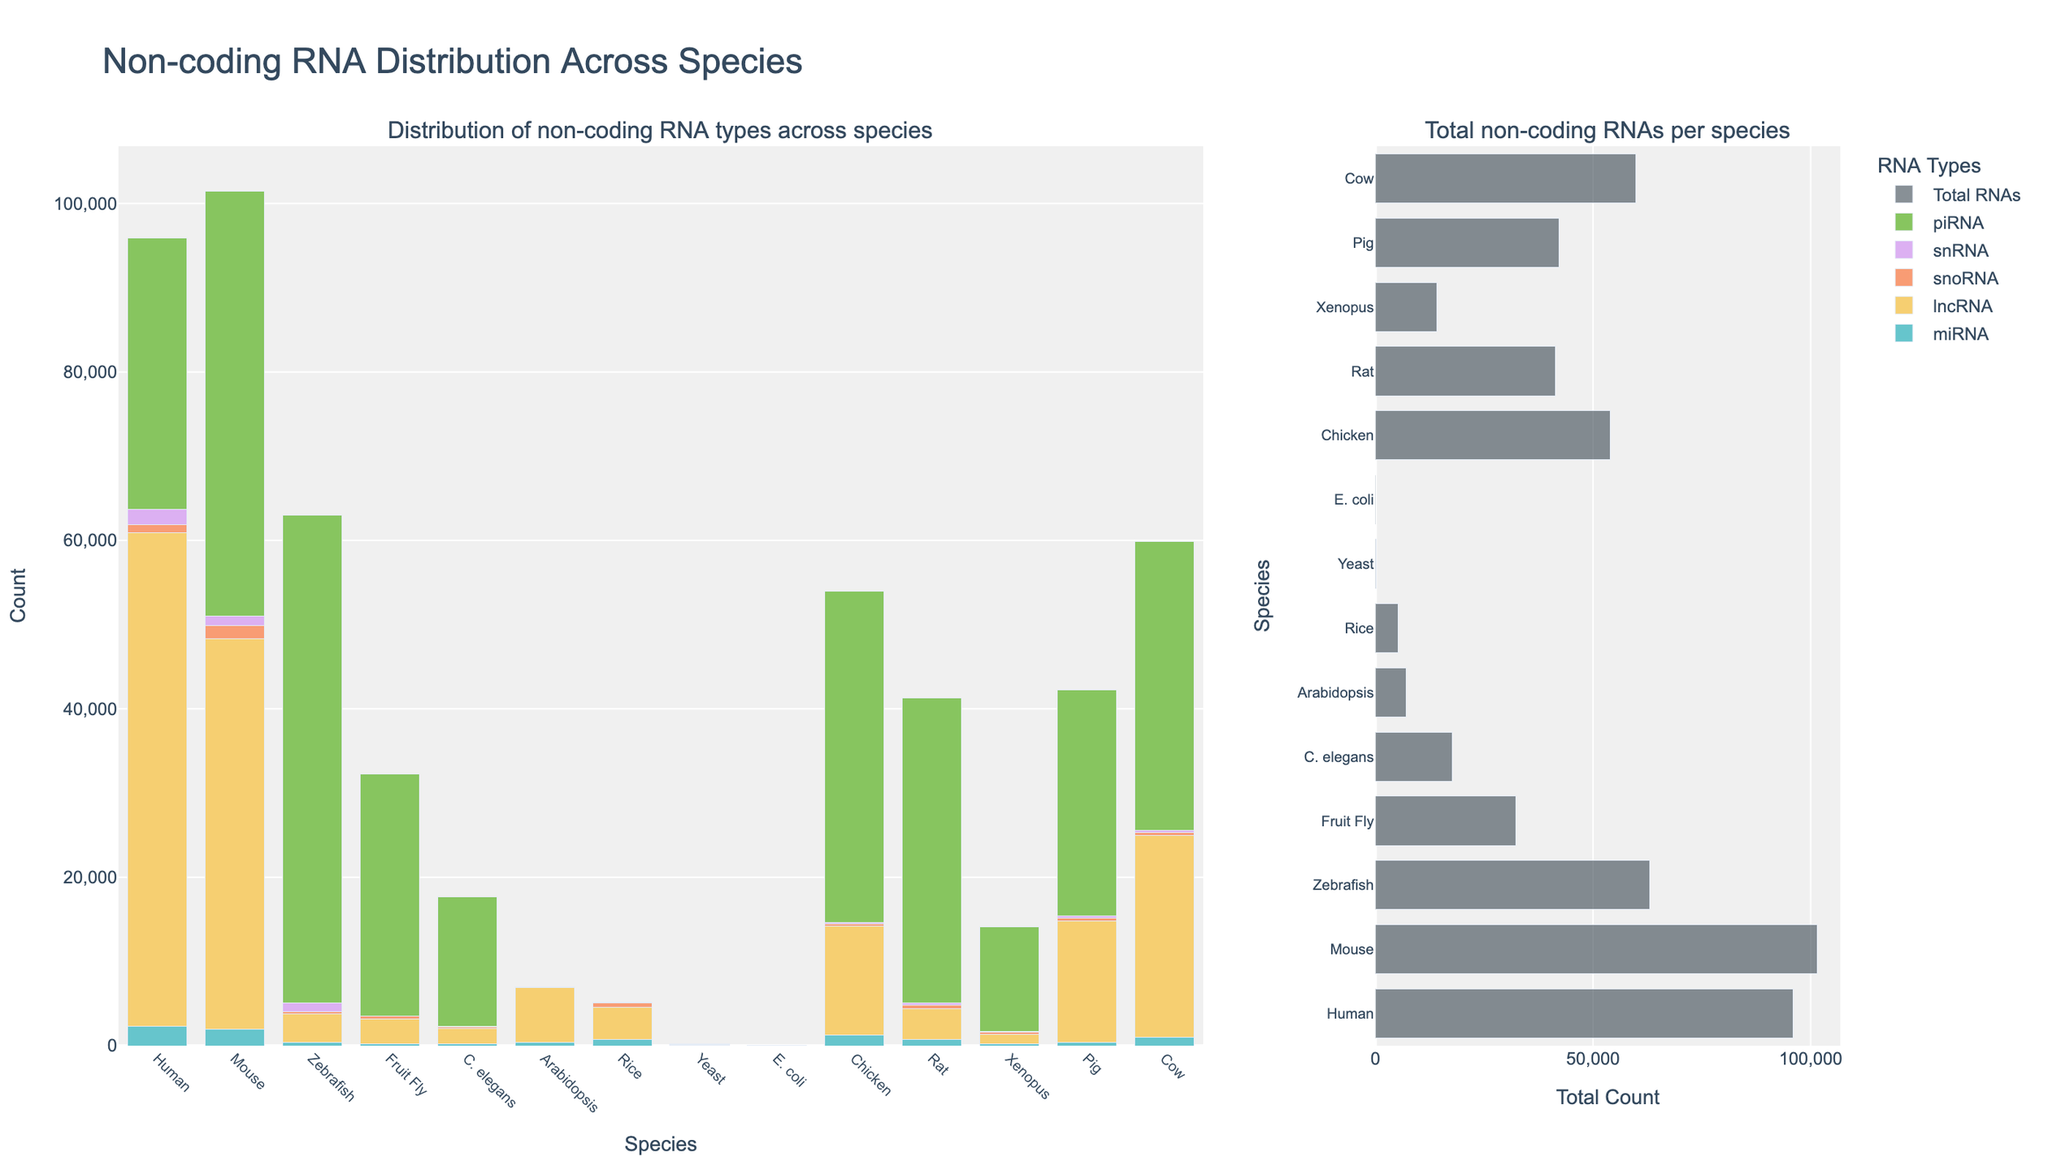Which species has the highest count of miRNA? By visually inspecting the bars corresponding to miRNA across different species, Human has the tallest bar, indicating it has the highest count of miRNA.
Answer: Human How many species have no recorded piRNA? Check the bars for piRNA across all species. E. coli, Yeast, Arabidopsis, and Rice show no presence of piRNA. Count these species.
Answer: 4 Which species has a higher total count of non-coding RNA, Mouse or Pig? Compare the total heights of RNA (the sum bar) for Mouse and Pig by inspecting the subplot for total non-coding RNA counts. Mouse has a higher bar compared to Pig.
Answer: Mouse What is the difference in snoRNA count between Human and Chicken? Human has a snoRNA count of 943, and Chicken has a count of 236. Subtract the Chicken count from the Human count: 943 - 236.
Answer: 707 Which RNA type is most abundant in Zebrafish? Look at the different bars for Zebrafish. The tallest bar corresponds to the piRNA, making it the most abundant RNA type in Zebrafish.
Answer: piRNA Does Yeast or E. coli have more types of non-coding RNAs present? Compare the presence of non-coding RNA types in Yeast (miRNA, lncRNA, snoRNA, snRNA) and E. coli (only lncRNA). Yeast has more types.
Answer: Yeast Which species has the smallest total count of non-coding RNAs? Look at the heights of the total non-coding RNA bars in the subplot, E. coli has the smallest bar.
Answer: E. coli What is the total count of lncRNA in Mouse and Pig combined? Mouse has 46,384 lncRNA and Pig has 14,429 lncRNA. Sum these counts: 46,384 + 14,429.
Answer: 60,813 How many more piRNA does Mouse have compared to Rat? Mouse has 50,423 piRNA, and Rat has 36,178 piRNA. Subtract Rat's count from Mouse's: 50,423 - 36,178.
Answer: 14,245 What is the sum of snRNA in Human, Chicken, and Fruit Fly? Human has 1,807 snRNA, Chicken has 193 snRNA, and Fruit Fly has 31 snRNA. Sum these counts: 1,807 + 193 + 31.
Answer: 2,031 Is the total count of non-coding RNA in Cow greater than that in Human? Compare the total heights of non-coding RNA bars for Cow and Human in the subplot. Cow's bar is shorter than Human's, so Cow has a lesser count.
Answer: No 